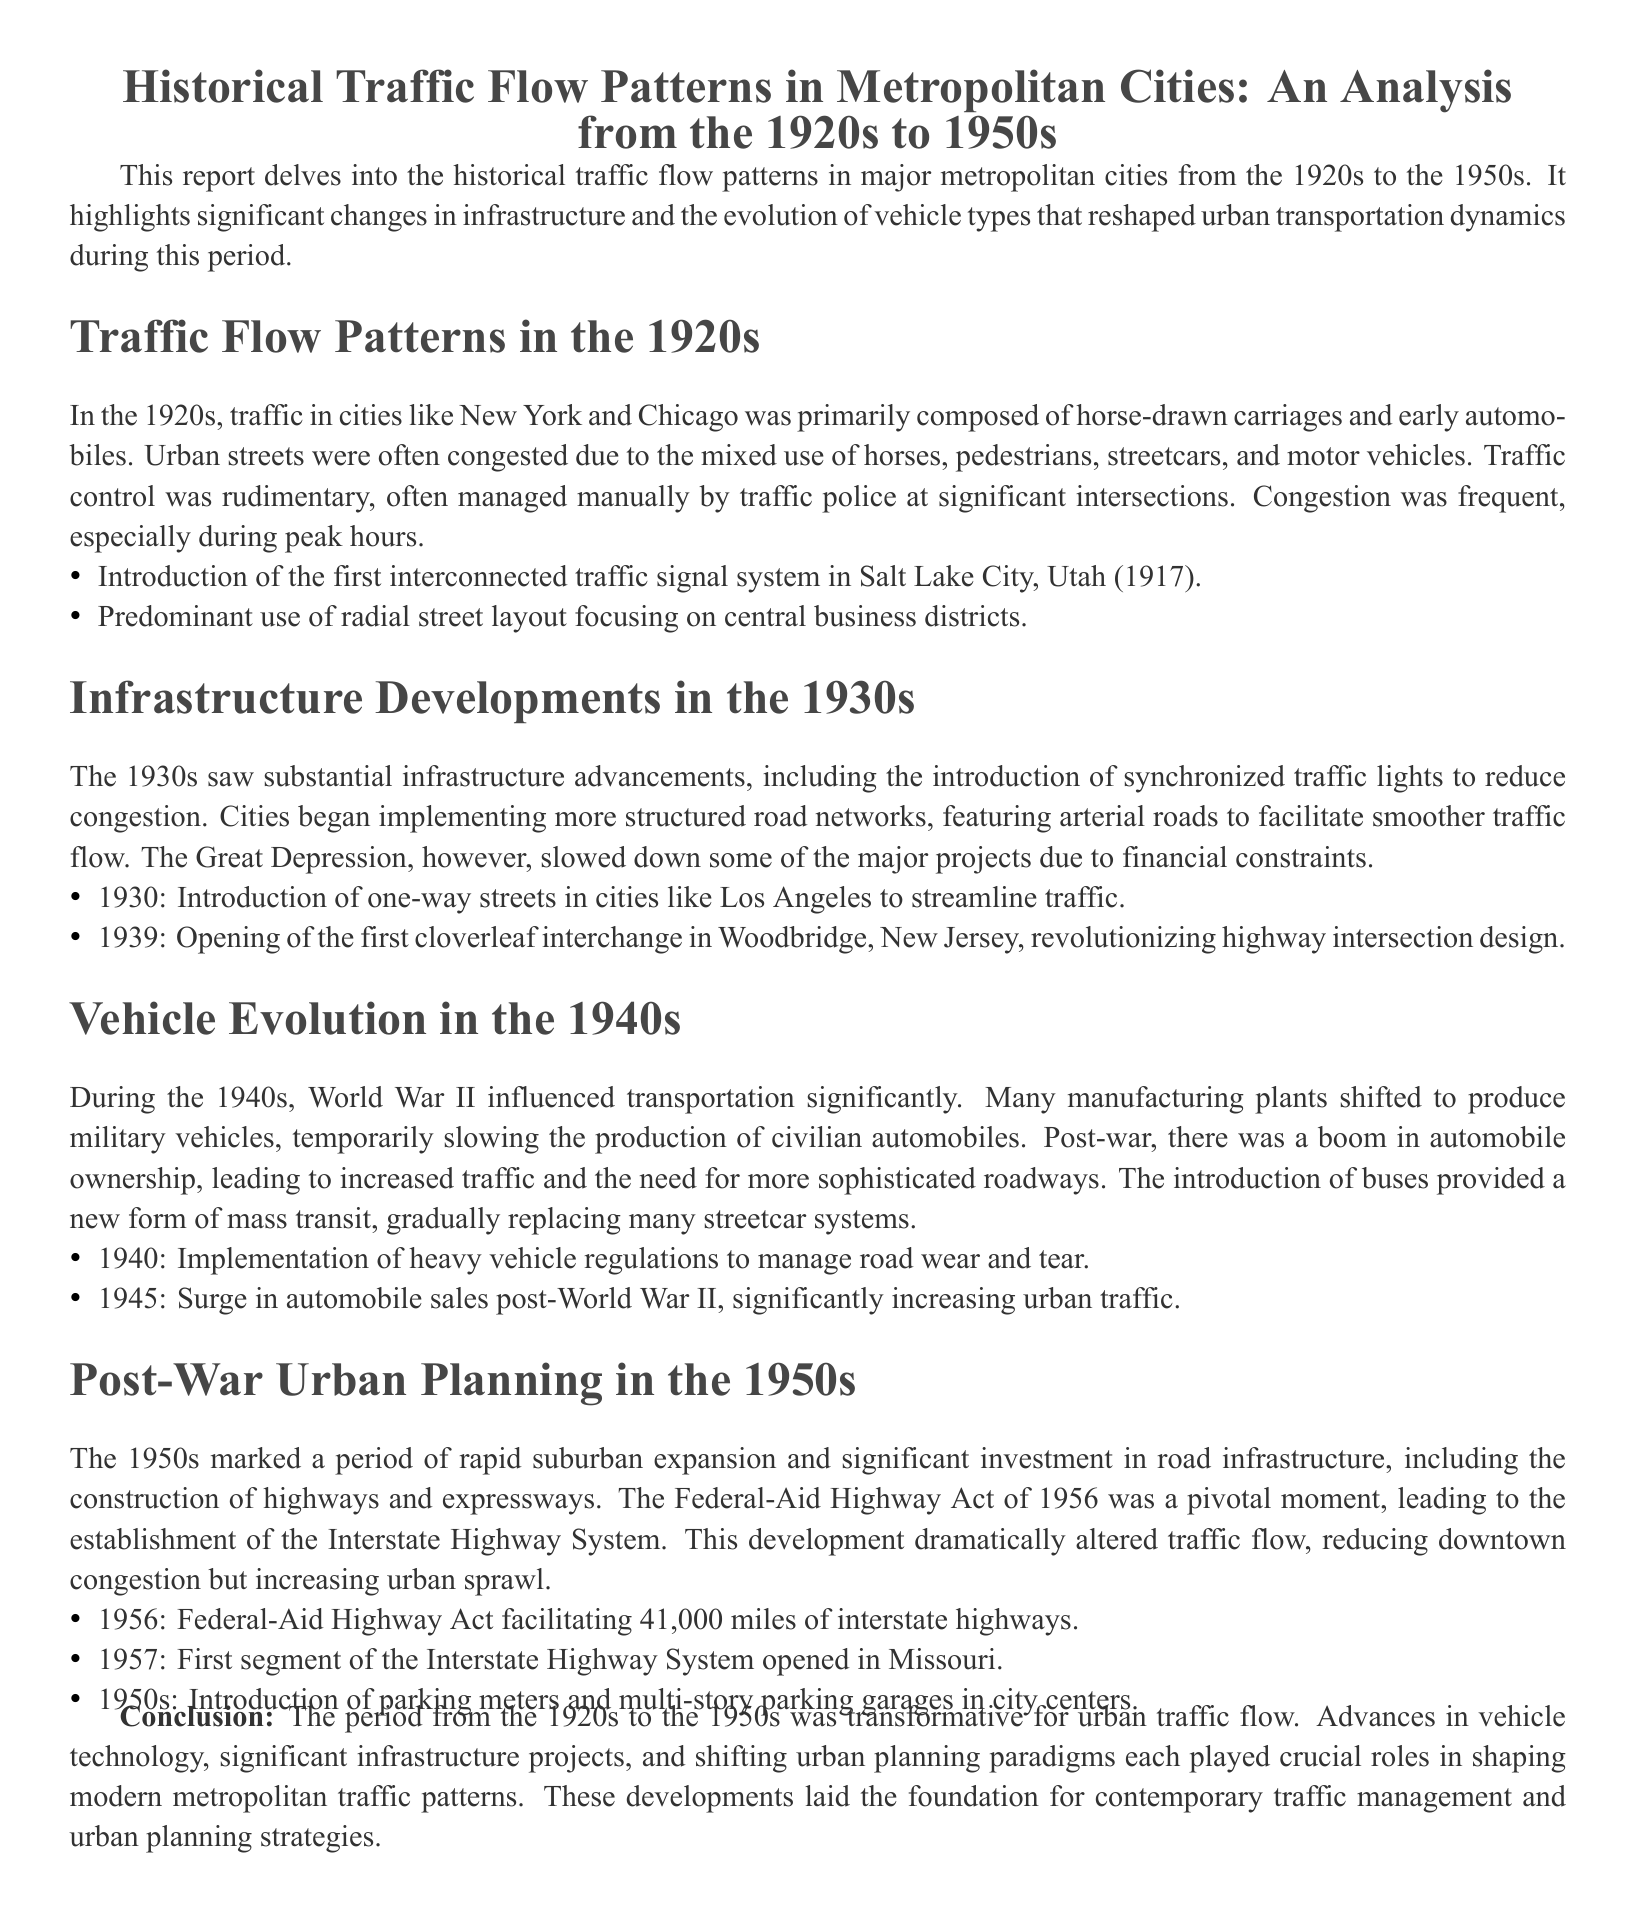What was the primary composition of traffic in the 1920s? The report states that traffic in the 1920s was primarily composed of horse-drawn carriages and early automobiles.
Answer: horse-drawn carriages and early automobiles What significant traffic control innovation occurred in 1917? The document mentions the introduction of the first interconnected traffic signal system in Salt Lake City, Utah.
Answer: interconnected traffic signal system What was introduced in Los Angeles in 1930 to help with traffic? The report notes the introduction of one-way streets in cities like Los Angeles to streamline traffic.
Answer: one-way streets What act in 1956 significantly impacted urban traffic flow? The Federal-Aid Highway Act of 1956 is highlighted as a pivotal moment leading to the establishment of the Interstate Highway System.
Answer: Federal-Aid Highway Act What vehicle type began to replace many streetcar systems in the 1940s? The document indicates that the introduction of buses provided a new form of mass transit, gradually replacing many streetcar systems.
Answer: buses Which city saw the opening of the first cloverleaf interchange in 1939? The report specifies that the first cloverleaf interchange opened in Woodbridge, New Jersey.
Answer: Woodbridge, New Jersey What was a result of the post-war surge in automobile sales in 1945? According to the analysis, the surge significantly increased urban traffic and the need for more sophisticated roadways.
Answer: increased urban traffic What was the focus of urban streets in the 1920s? The document states that urban streets predominantly utilized a radial street layout focusing on central business districts.
Answer: radial street layout How many miles of interstate highways were facilitated by the Federal-Aid Highway Act? The document indicates that the Federal-Aid Highway Act facilitated 41,000 miles of interstate highways.
Answer: 41,000 miles 